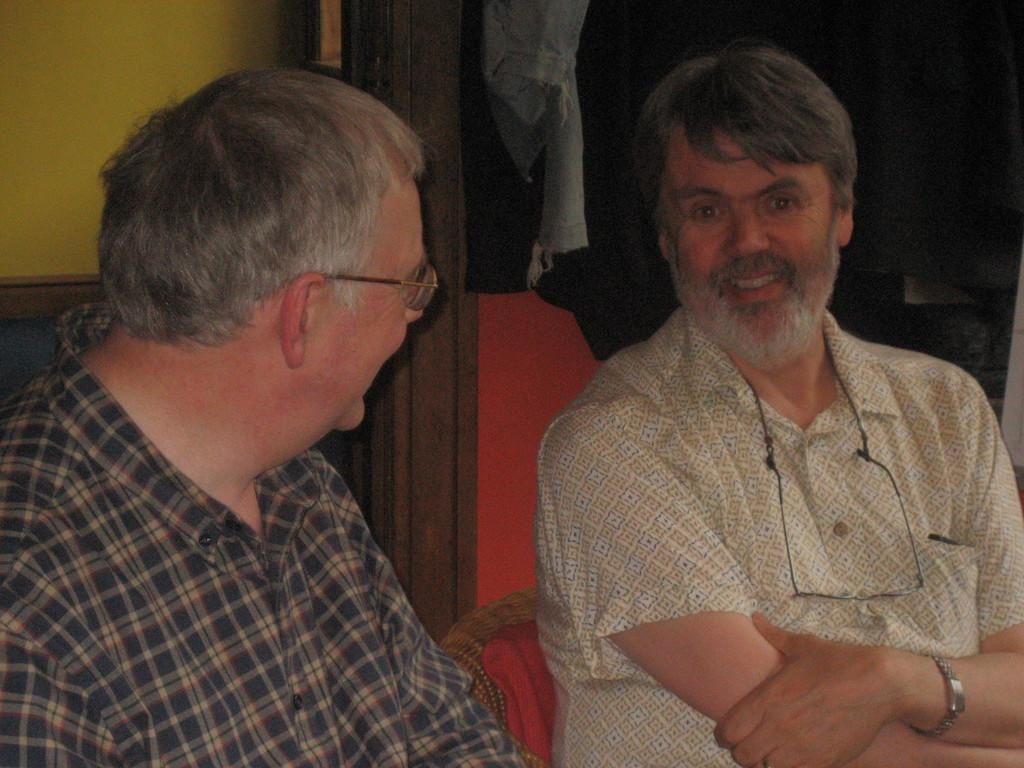How many people are in the image? There are two persons in the image. What are the two persons doing? The two persons are sitting. What is the facial expression of the two persons? The two persons are smiling. Can you describe any accessories worn by one of the persons? One of the persons is wearing glasses. What can be seen in the background of the image? There is a wall in the background of the image. What is the opinion of the clouds in the image? There are no clouds present in the image, so it is not possible to determine their opinion. 